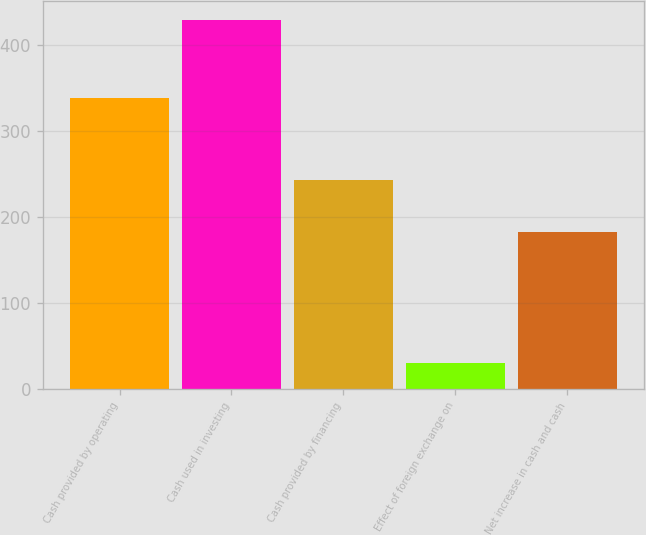<chart> <loc_0><loc_0><loc_500><loc_500><bar_chart><fcel>Cash provided by operating<fcel>Cash used in investing<fcel>Cash provided by financing<fcel>Effect of foreign exchange on<fcel>Net increase in cash and cash<nl><fcel>338<fcel>429<fcel>243<fcel>30<fcel>182<nl></chart> 